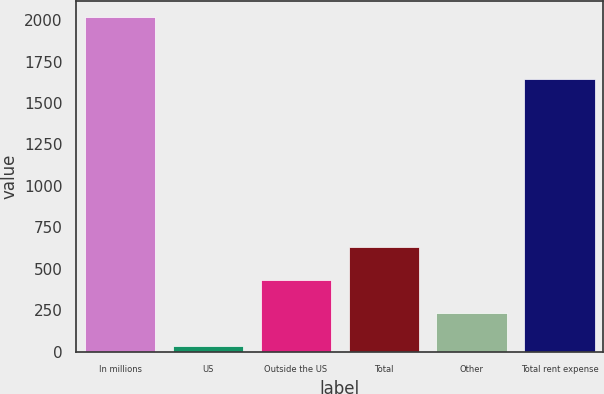Convert chart to OTSL. <chart><loc_0><loc_0><loc_500><loc_500><bar_chart><fcel>In millions<fcel>US<fcel>Outside the US<fcel>Total<fcel>Other<fcel>Total rent expense<nl><fcel>2017<fcel>37.4<fcel>433.32<fcel>631.28<fcel>235.36<fcel>1644.5<nl></chart> 